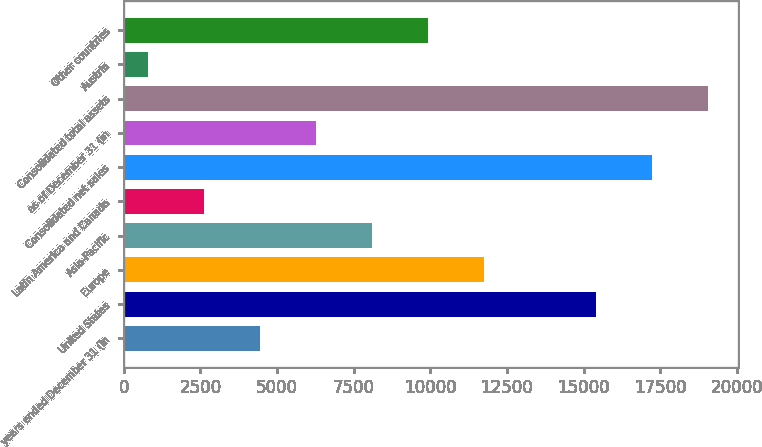Convert chart. <chart><loc_0><loc_0><loc_500><loc_500><bar_chart><fcel>years ended December 31 (in<fcel>United States<fcel>Europe<fcel>Asia-Pacific<fcel>Latin America and Canada<fcel>Consolidated net sales<fcel>as of December 31 (in<fcel>Consolidated total assets<fcel>Austria<fcel>Other countries<nl><fcel>4443.4<fcel>15415.6<fcel>11758.2<fcel>8100.8<fcel>2614.7<fcel>17244.3<fcel>6272.1<fcel>19073<fcel>786<fcel>9929.5<nl></chart> 